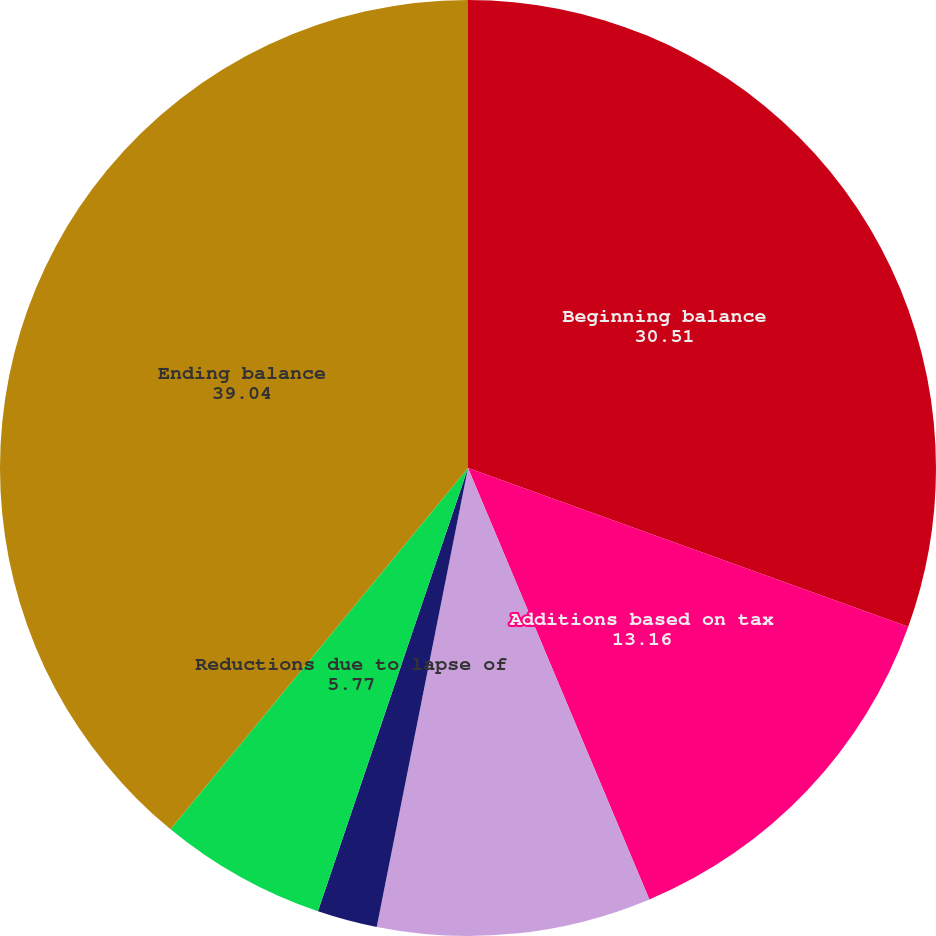<chart> <loc_0><loc_0><loc_500><loc_500><pie_chart><fcel>Beginning balance<fcel>Additions based on tax<fcel>Additions/(reductions) based<fcel>Reductions due to settlements<fcel>Reductions due to lapse of<fcel>Ending balance<nl><fcel>30.51%<fcel>13.16%<fcel>9.46%<fcel>2.07%<fcel>5.77%<fcel>39.04%<nl></chart> 